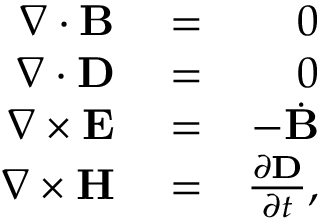Convert formula to latex. <formula><loc_0><loc_0><loc_500><loc_500>\begin{array} { r l r } { \nabla \cdot { B } } & = } & { 0 } \\ { \nabla \cdot { D } } & = } & { 0 } \\ { \nabla \times { E } } & = } & { - \dot { B } } \\ { \nabla \times { H } } & = } & { \frac { \partial { D } } { \partial t } , } \end{array}</formula> 